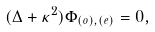Convert formula to latex. <formula><loc_0><loc_0><loc_500><loc_500>( \Delta + \kappa ^ { 2 } ) \Phi _ { ( o ) , ( e ) } = 0 ,</formula> 